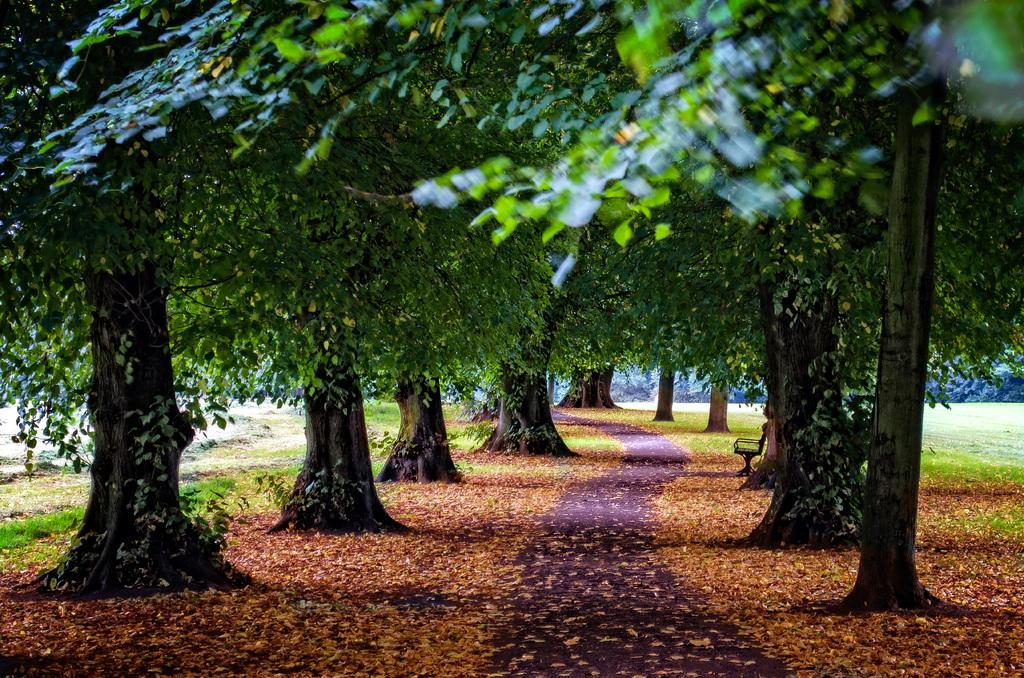What is the main feature of the image? There is a road in the image. What can be seen on the ground in the image? There are leaves on the ground in the image. What type of vegetation is present in the image? There are many trees in the image. Is there any seating visible in the image? Yes, there is a bench in the image. How many chickens are crossing the road in the image? There are no chickens present in the image. What type of rice is being served on the bench in the image? There is no rice or serving activity visible in the image. 